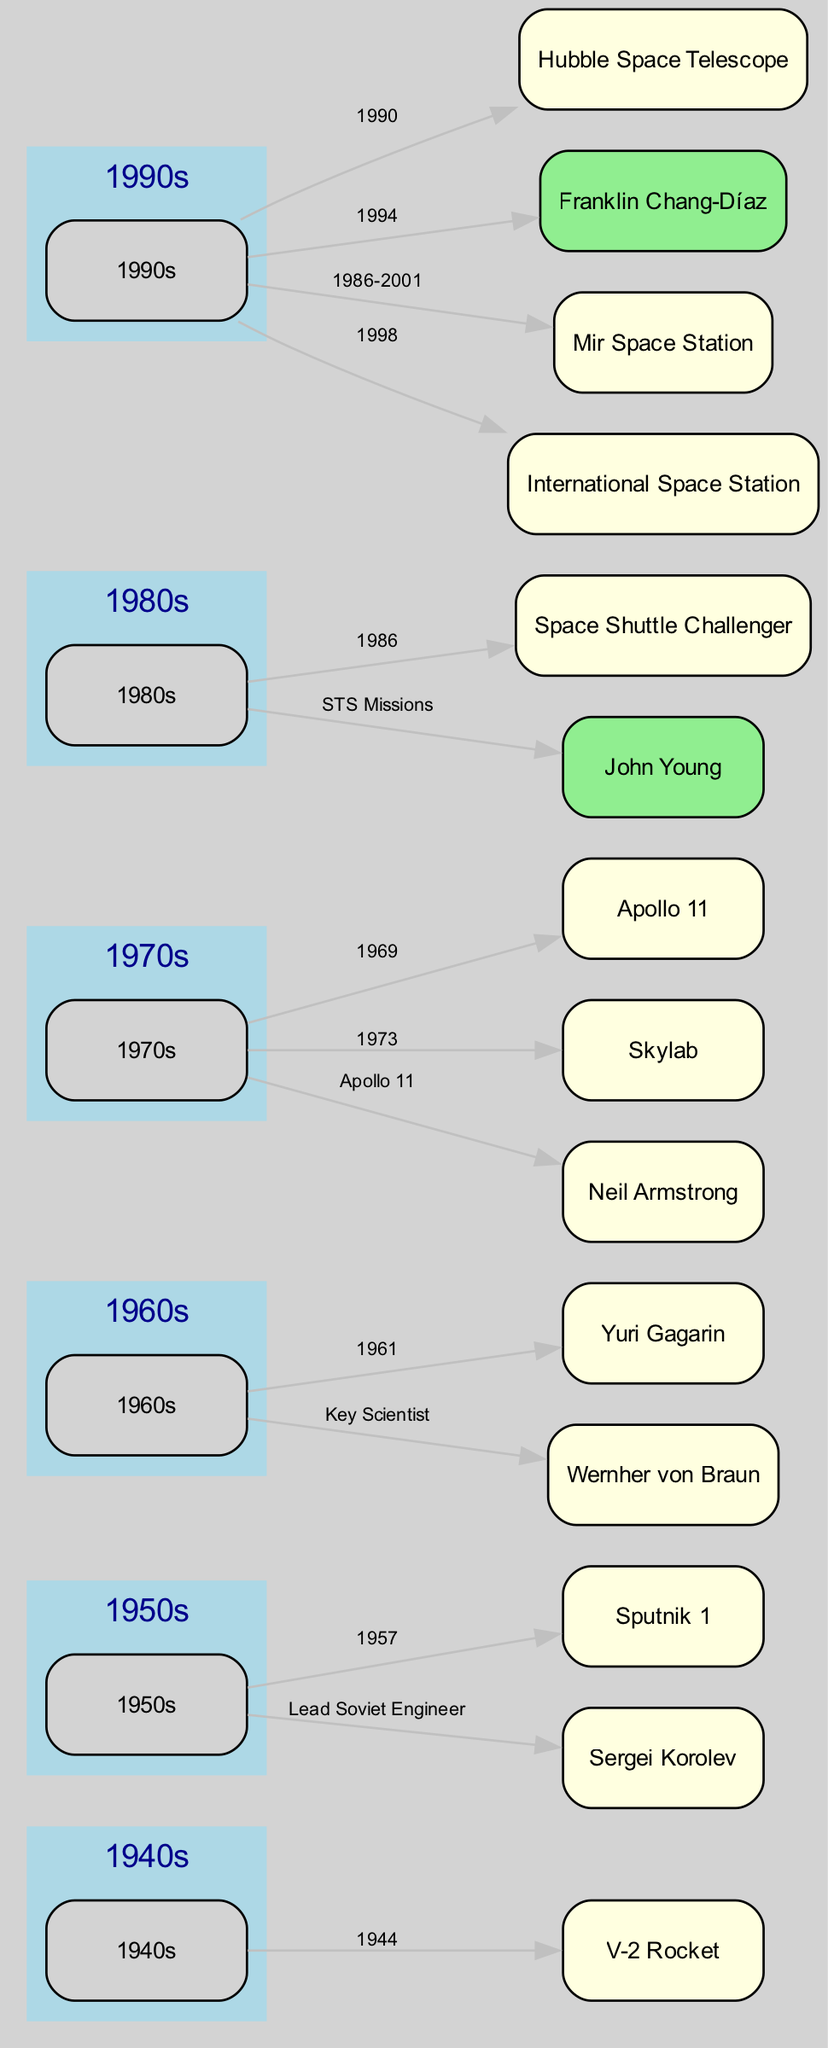What space mission is associated with the decade of the 1960s? The 1960s is associated with the mission of Yuri Gagarin, who was the first human in space, as indicated by the label connected to the 1960s node in the diagram.
Answer: Yuri Gagarin Who developed the V-2 Rocket? The V-2 Rocket is linked to Wernher von Braun, who is identified specifically as the developer of this rocket. This connection is represented as an edge between the two nodes.
Answer: Wernher von Braun In which year did Apollo 11 land on the Moon? Apollo 11 is linked to the year 1969, as per the edge labeled with that year connecting the Apollo 11 node to the Moon Landings and Space Stations node from the 1970s.
Answer: 1969 Which mission is indicated as the first artificial satellite? The first artificial satellite is represented by the node Sputnik 1, which connects to the 1950s node, highlighting its significance during that decade.
Answer: Sputnik 1 What does the International Space Station signify in the diagram? The International Space Station, labeled within the 1990s decade, signifies global collaboration in space, as denoted by the title associated with this node in the diagram.
Answer: Global Collaboration in Space How many nodes depict events in the 1980s alone? The diagram features two prominent nodes related to the 1980s: the Space Shuttle Challenger and John Young, the longest-serving astronaut connected to the Shuttle Era.
Answer: 2 What major tragedy is connected to the Shuttle Era? The major tragedy linked to the Shuttle Era is the Space Shuttle Challenger disaster, represented by a specific node that relates directly to the 1980s node.
Answer: Space Shuttle Challenger Which scientist is recognized as the chief designer of the Soviet Space Program? The diagram indicates Sergei Korolev as the chief designer of the Soviet Space Program, connected specifically to the Cold War and Space Race node from the 1950s.
Answer: Sergei Korolev What significant observatory was launched in 1990? The Hubble Space Telescope is the significant observatory launched in 1990, as noted within the 1990s decade, highlighting its major astronomical observations.
Answer: Hubble Space Telescope 